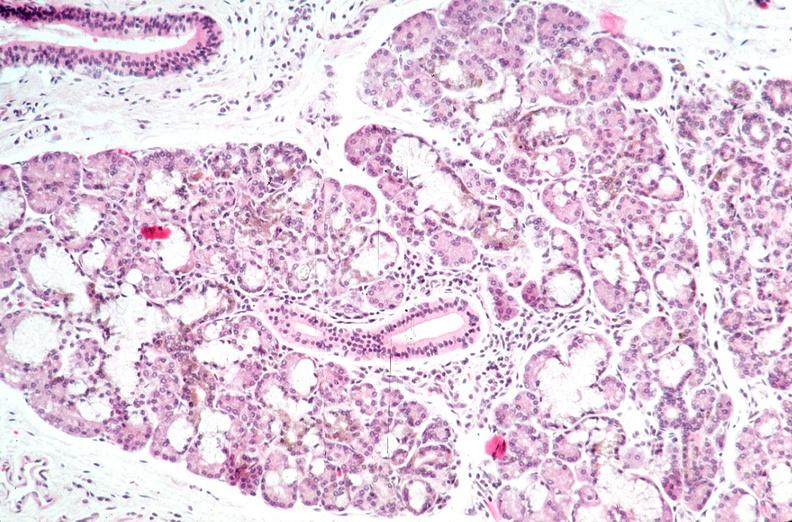does this image show pancreas, hemochromatosis?
Answer the question using a single word or phrase. Yes 